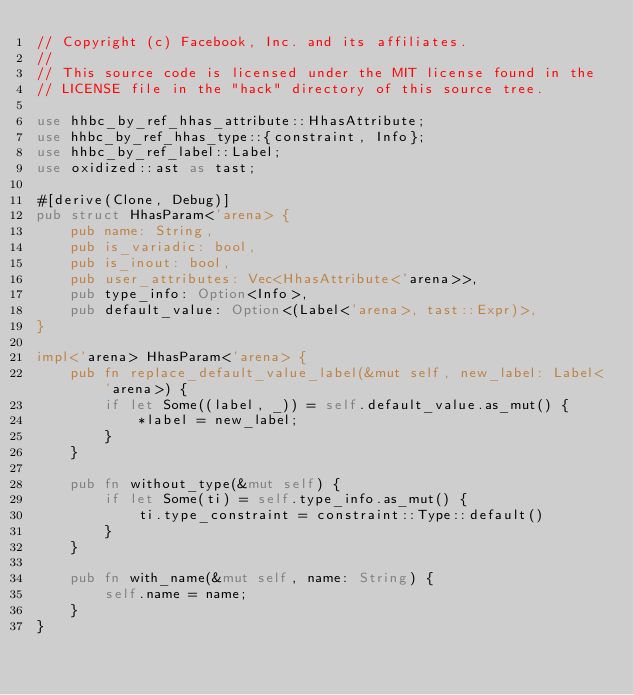Convert code to text. <code><loc_0><loc_0><loc_500><loc_500><_Rust_>// Copyright (c) Facebook, Inc. and its affiliates.
//
// This source code is licensed under the MIT license found in the
// LICENSE file in the "hack" directory of this source tree.

use hhbc_by_ref_hhas_attribute::HhasAttribute;
use hhbc_by_ref_hhas_type::{constraint, Info};
use hhbc_by_ref_label::Label;
use oxidized::ast as tast;

#[derive(Clone, Debug)]
pub struct HhasParam<'arena> {
    pub name: String,
    pub is_variadic: bool,
    pub is_inout: bool,
    pub user_attributes: Vec<HhasAttribute<'arena>>,
    pub type_info: Option<Info>,
    pub default_value: Option<(Label<'arena>, tast::Expr)>,
}

impl<'arena> HhasParam<'arena> {
    pub fn replace_default_value_label(&mut self, new_label: Label<'arena>) {
        if let Some((label, _)) = self.default_value.as_mut() {
            *label = new_label;
        }
    }

    pub fn without_type(&mut self) {
        if let Some(ti) = self.type_info.as_mut() {
            ti.type_constraint = constraint::Type::default()
        }
    }

    pub fn with_name(&mut self, name: String) {
        self.name = name;
    }
}
</code> 